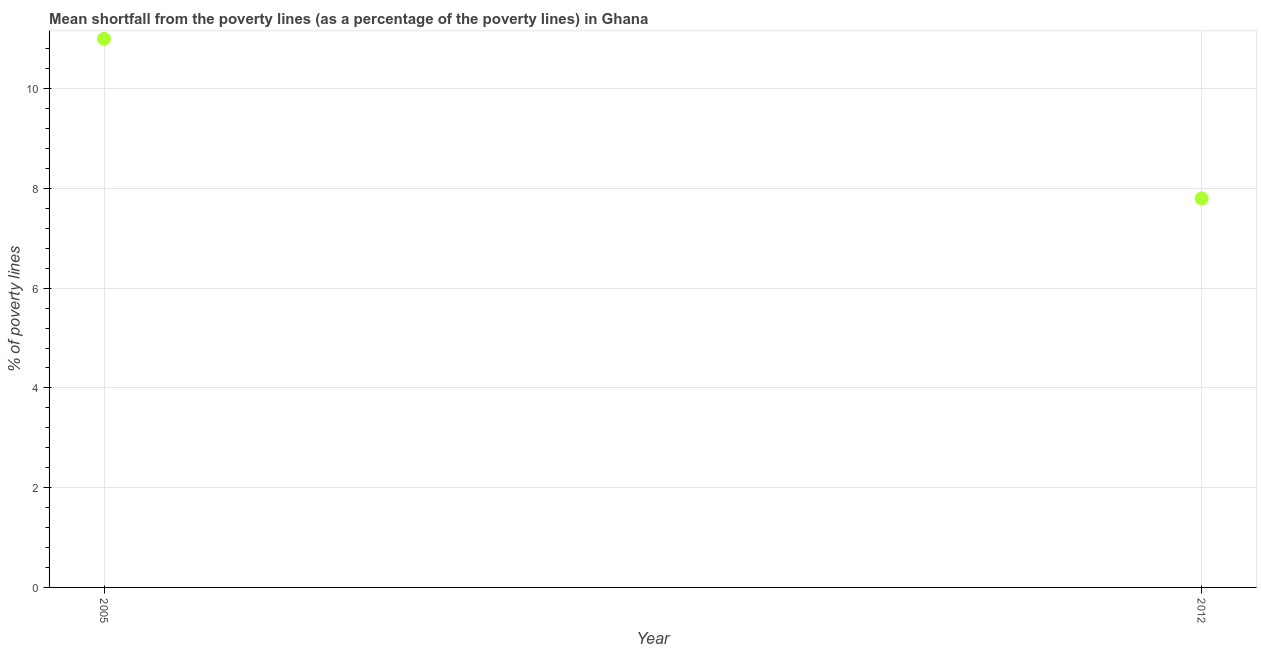What is the poverty gap at national poverty lines in 2012?
Your answer should be very brief. 7.8. Across all years, what is the minimum poverty gap at national poverty lines?
Provide a short and direct response. 7.8. In which year was the poverty gap at national poverty lines maximum?
Make the answer very short. 2005. What is the median poverty gap at national poverty lines?
Your answer should be very brief. 9.4. What is the ratio of the poverty gap at national poverty lines in 2005 to that in 2012?
Make the answer very short. 1.41. In how many years, is the poverty gap at national poverty lines greater than the average poverty gap at national poverty lines taken over all years?
Make the answer very short. 1. Does the poverty gap at national poverty lines monotonically increase over the years?
Your response must be concise. No. How many dotlines are there?
Provide a short and direct response. 1. What is the difference between two consecutive major ticks on the Y-axis?
Make the answer very short. 2. Are the values on the major ticks of Y-axis written in scientific E-notation?
Your answer should be very brief. No. Does the graph contain grids?
Offer a very short reply. Yes. What is the title of the graph?
Your response must be concise. Mean shortfall from the poverty lines (as a percentage of the poverty lines) in Ghana. What is the label or title of the Y-axis?
Make the answer very short. % of poverty lines. What is the % of poverty lines in 2012?
Offer a terse response. 7.8. What is the difference between the % of poverty lines in 2005 and 2012?
Provide a short and direct response. 3.2. What is the ratio of the % of poverty lines in 2005 to that in 2012?
Offer a terse response. 1.41. 